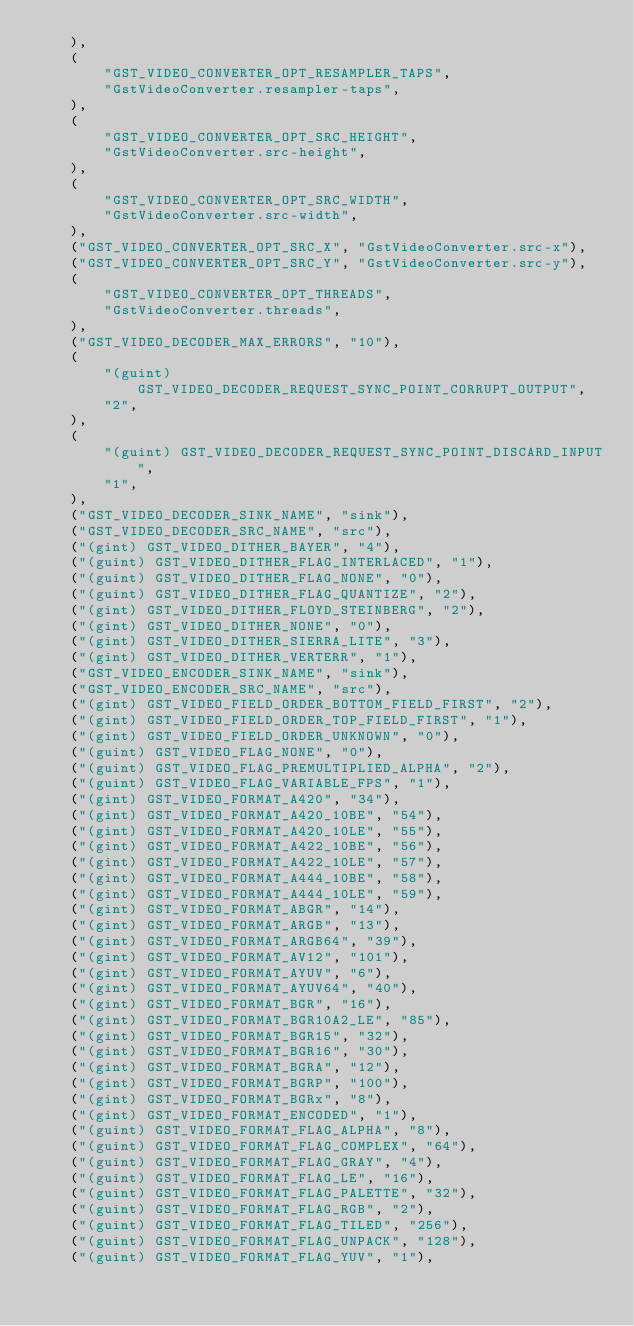<code> <loc_0><loc_0><loc_500><loc_500><_Rust_>    ),
    (
        "GST_VIDEO_CONVERTER_OPT_RESAMPLER_TAPS",
        "GstVideoConverter.resampler-taps",
    ),
    (
        "GST_VIDEO_CONVERTER_OPT_SRC_HEIGHT",
        "GstVideoConverter.src-height",
    ),
    (
        "GST_VIDEO_CONVERTER_OPT_SRC_WIDTH",
        "GstVideoConverter.src-width",
    ),
    ("GST_VIDEO_CONVERTER_OPT_SRC_X", "GstVideoConverter.src-x"),
    ("GST_VIDEO_CONVERTER_OPT_SRC_Y", "GstVideoConverter.src-y"),
    (
        "GST_VIDEO_CONVERTER_OPT_THREADS",
        "GstVideoConverter.threads",
    ),
    ("GST_VIDEO_DECODER_MAX_ERRORS", "10"),
    (
        "(guint) GST_VIDEO_DECODER_REQUEST_SYNC_POINT_CORRUPT_OUTPUT",
        "2",
    ),
    (
        "(guint) GST_VIDEO_DECODER_REQUEST_SYNC_POINT_DISCARD_INPUT",
        "1",
    ),
    ("GST_VIDEO_DECODER_SINK_NAME", "sink"),
    ("GST_VIDEO_DECODER_SRC_NAME", "src"),
    ("(gint) GST_VIDEO_DITHER_BAYER", "4"),
    ("(guint) GST_VIDEO_DITHER_FLAG_INTERLACED", "1"),
    ("(guint) GST_VIDEO_DITHER_FLAG_NONE", "0"),
    ("(guint) GST_VIDEO_DITHER_FLAG_QUANTIZE", "2"),
    ("(gint) GST_VIDEO_DITHER_FLOYD_STEINBERG", "2"),
    ("(gint) GST_VIDEO_DITHER_NONE", "0"),
    ("(gint) GST_VIDEO_DITHER_SIERRA_LITE", "3"),
    ("(gint) GST_VIDEO_DITHER_VERTERR", "1"),
    ("GST_VIDEO_ENCODER_SINK_NAME", "sink"),
    ("GST_VIDEO_ENCODER_SRC_NAME", "src"),
    ("(gint) GST_VIDEO_FIELD_ORDER_BOTTOM_FIELD_FIRST", "2"),
    ("(gint) GST_VIDEO_FIELD_ORDER_TOP_FIELD_FIRST", "1"),
    ("(gint) GST_VIDEO_FIELD_ORDER_UNKNOWN", "0"),
    ("(guint) GST_VIDEO_FLAG_NONE", "0"),
    ("(guint) GST_VIDEO_FLAG_PREMULTIPLIED_ALPHA", "2"),
    ("(guint) GST_VIDEO_FLAG_VARIABLE_FPS", "1"),
    ("(gint) GST_VIDEO_FORMAT_A420", "34"),
    ("(gint) GST_VIDEO_FORMAT_A420_10BE", "54"),
    ("(gint) GST_VIDEO_FORMAT_A420_10LE", "55"),
    ("(gint) GST_VIDEO_FORMAT_A422_10BE", "56"),
    ("(gint) GST_VIDEO_FORMAT_A422_10LE", "57"),
    ("(gint) GST_VIDEO_FORMAT_A444_10BE", "58"),
    ("(gint) GST_VIDEO_FORMAT_A444_10LE", "59"),
    ("(gint) GST_VIDEO_FORMAT_ABGR", "14"),
    ("(gint) GST_VIDEO_FORMAT_ARGB", "13"),
    ("(gint) GST_VIDEO_FORMAT_ARGB64", "39"),
    ("(gint) GST_VIDEO_FORMAT_AV12", "101"),
    ("(gint) GST_VIDEO_FORMAT_AYUV", "6"),
    ("(gint) GST_VIDEO_FORMAT_AYUV64", "40"),
    ("(gint) GST_VIDEO_FORMAT_BGR", "16"),
    ("(gint) GST_VIDEO_FORMAT_BGR10A2_LE", "85"),
    ("(gint) GST_VIDEO_FORMAT_BGR15", "32"),
    ("(gint) GST_VIDEO_FORMAT_BGR16", "30"),
    ("(gint) GST_VIDEO_FORMAT_BGRA", "12"),
    ("(gint) GST_VIDEO_FORMAT_BGRP", "100"),
    ("(gint) GST_VIDEO_FORMAT_BGRx", "8"),
    ("(gint) GST_VIDEO_FORMAT_ENCODED", "1"),
    ("(guint) GST_VIDEO_FORMAT_FLAG_ALPHA", "8"),
    ("(guint) GST_VIDEO_FORMAT_FLAG_COMPLEX", "64"),
    ("(guint) GST_VIDEO_FORMAT_FLAG_GRAY", "4"),
    ("(guint) GST_VIDEO_FORMAT_FLAG_LE", "16"),
    ("(guint) GST_VIDEO_FORMAT_FLAG_PALETTE", "32"),
    ("(guint) GST_VIDEO_FORMAT_FLAG_RGB", "2"),
    ("(guint) GST_VIDEO_FORMAT_FLAG_TILED", "256"),
    ("(guint) GST_VIDEO_FORMAT_FLAG_UNPACK", "128"),
    ("(guint) GST_VIDEO_FORMAT_FLAG_YUV", "1"),</code> 